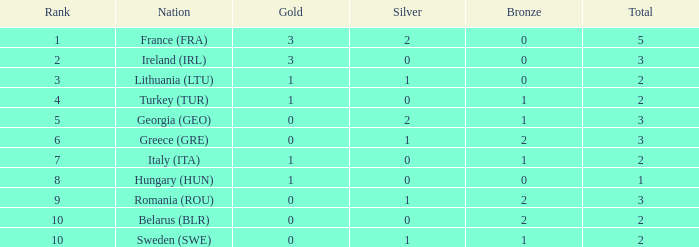What's the total when the gold is less than 0 and silver is less than 1? None. 